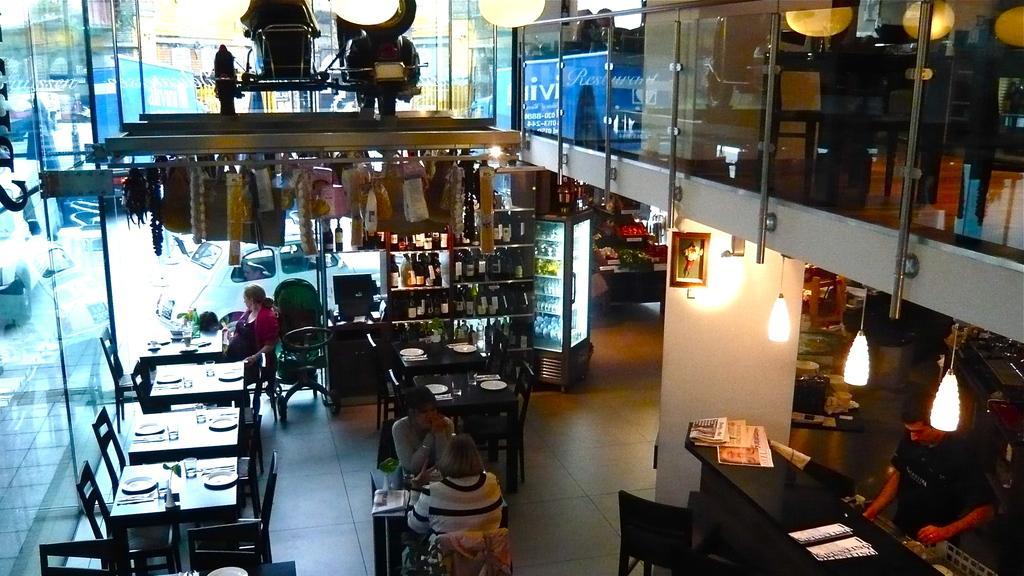Could you give a brief overview of what you see in this image? In this picture we can see three persons are sitting on the chairs. These are the tables. On the table there are plates, and glasses. This is floor. There is a rack and these are the bottles. This is wall and these are the lights. Here we can see a man who is standing on the floor. There are papers. This is glass and there is a refrigerator. Here we can see a vehicle. 